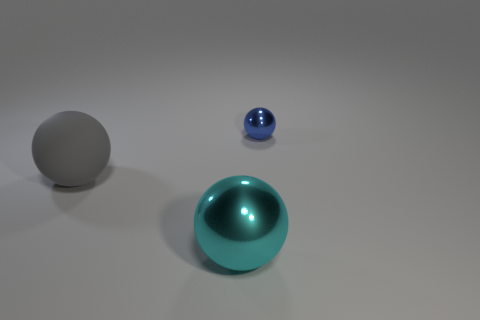Are there any reflections visible on the surface of the spheres? Yes, there are subtle reflections on the surfaces of the shiny spheres that hint at the surroundings and light source, though the specific objects reflecting are not visible in the image. 